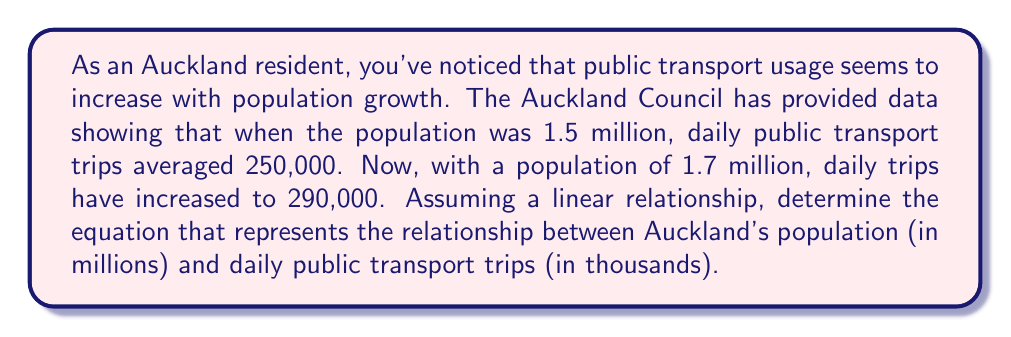Give your solution to this math problem. To find the linear equation, we'll use the point-slope form: $y - y_1 = m(x - x_1)$

1. Calculate the slope (m):
   $m = \frac{y_2 - y_1}{x_2 - x_1} = \frac{290 - 250}{1.7 - 1.5} = \frac{40}{0.2} = 200$

2. Choose one point, let's use $(x_1, y_1) = (1.5, 250)$

3. Substitute into the point-slope form:
   $y - 250 = 200(x - 1.5)$

4. Simplify:
   $y - 250 = 200x - 300$
   $y = 200x - 300 + 250$
   $y = 200x - 50$

5. Our final equation is:
   $y = 200x - 50$

Where $x$ is the population in millions and $y$ is the number of daily public transport trips in thousands.

To verify, we can check the other point (1.7, 290):
$290 = 200(1.7) - 50$
$290 = 340 - 50$
$290 = 290$ (This confirms our equation is correct)
Answer: $y = 200x - 50$, where $x$ is the population in millions and $y$ is the daily public transport trips in thousands. 